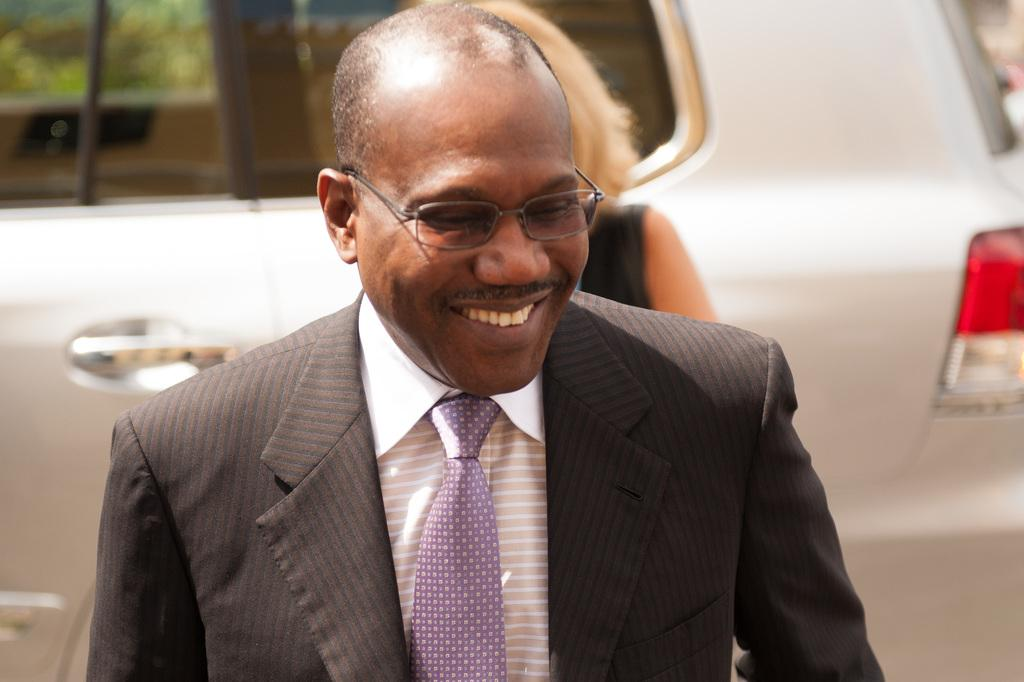What is the appearance of the man in the image? The man in the image is wearing a suit and smiling. Can you describe the presence of other people in the image? There is another person in the background of the image. What type of vehicle is visible in the image? There is a white car in the image. How many seats are available in the duck in the image? There is no duck present in the image, so it is not possible to determine the number of seats available. 